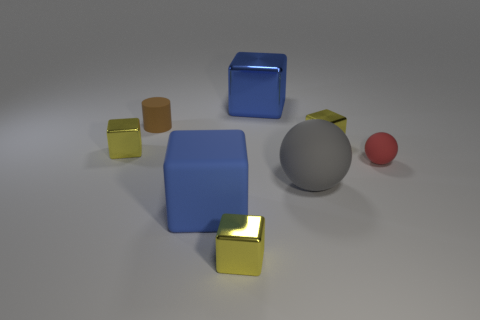Subtract all yellow cubes. How many were subtracted if there are1yellow cubes left? 2 Add 2 small blocks. How many objects exist? 10 Subtract all blue blocks. How many blocks are left? 3 Subtract all blue cubes. How many cubes are left? 3 Subtract all balls. How many objects are left? 6 Subtract 1 cylinders. How many cylinders are left? 0 Subtract all yellow cubes. Subtract all purple cylinders. How many cubes are left? 2 Subtract all blue blocks. How many purple cylinders are left? 0 Subtract all small blue cylinders. Subtract all yellow blocks. How many objects are left? 5 Add 3 red spheres. How many red spheres are left? 4 